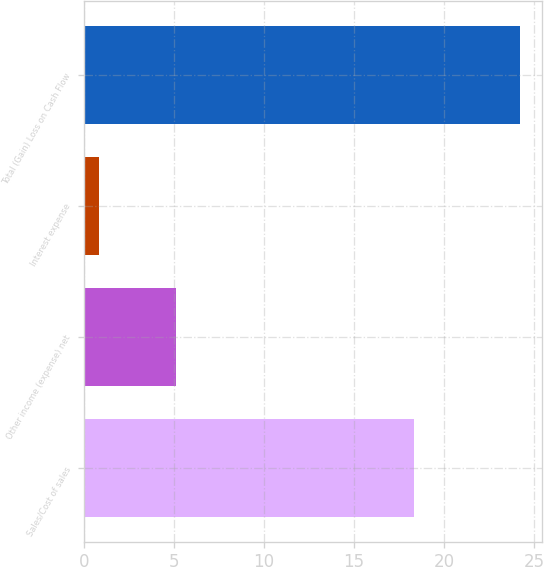<chart> <loc_0><loc_0><loc_500><loc_500><bar_chart><fcel>Sales/Cost of sales<fcel>Other income (expense) net<fcel>Interest expense<fcel>Total (Gain) Loss on Cash Flow<nl><fcel>18.3<fcel>5.1<fcel>0.8<fcel>24.2<nl></chart> 